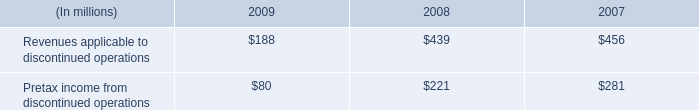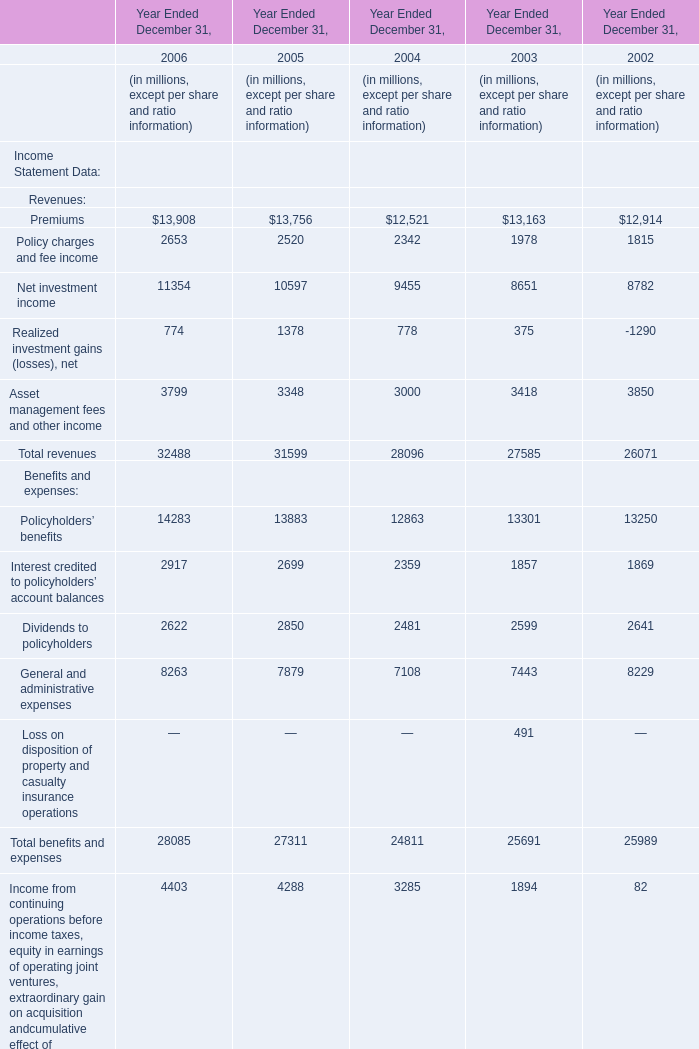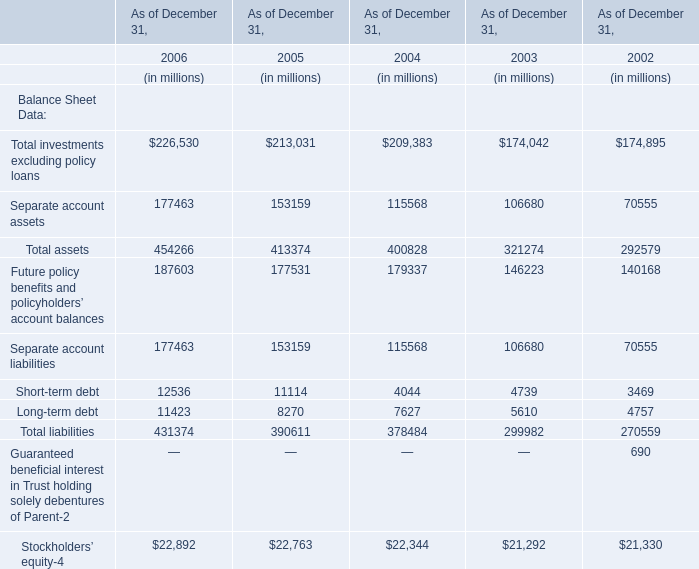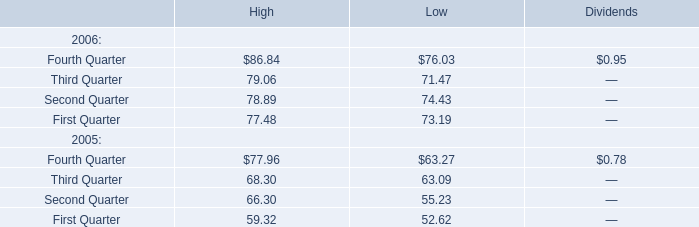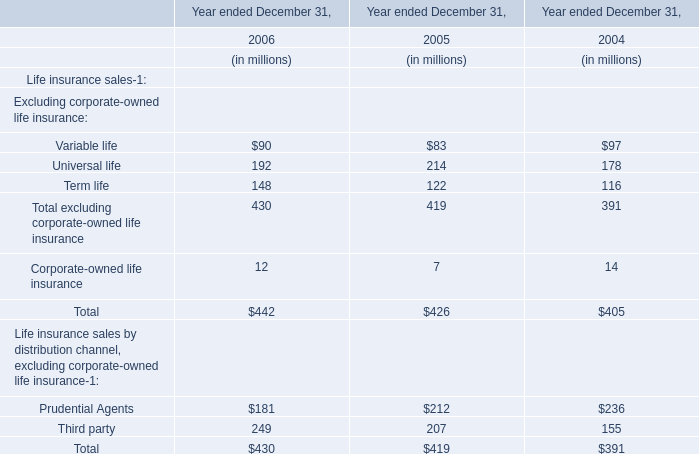by how much did revenues applicable to discontinued operations decrease from 2007 to 2009? 
Computations: ((188 - 456) / 456)
Answer: -0.58772. 